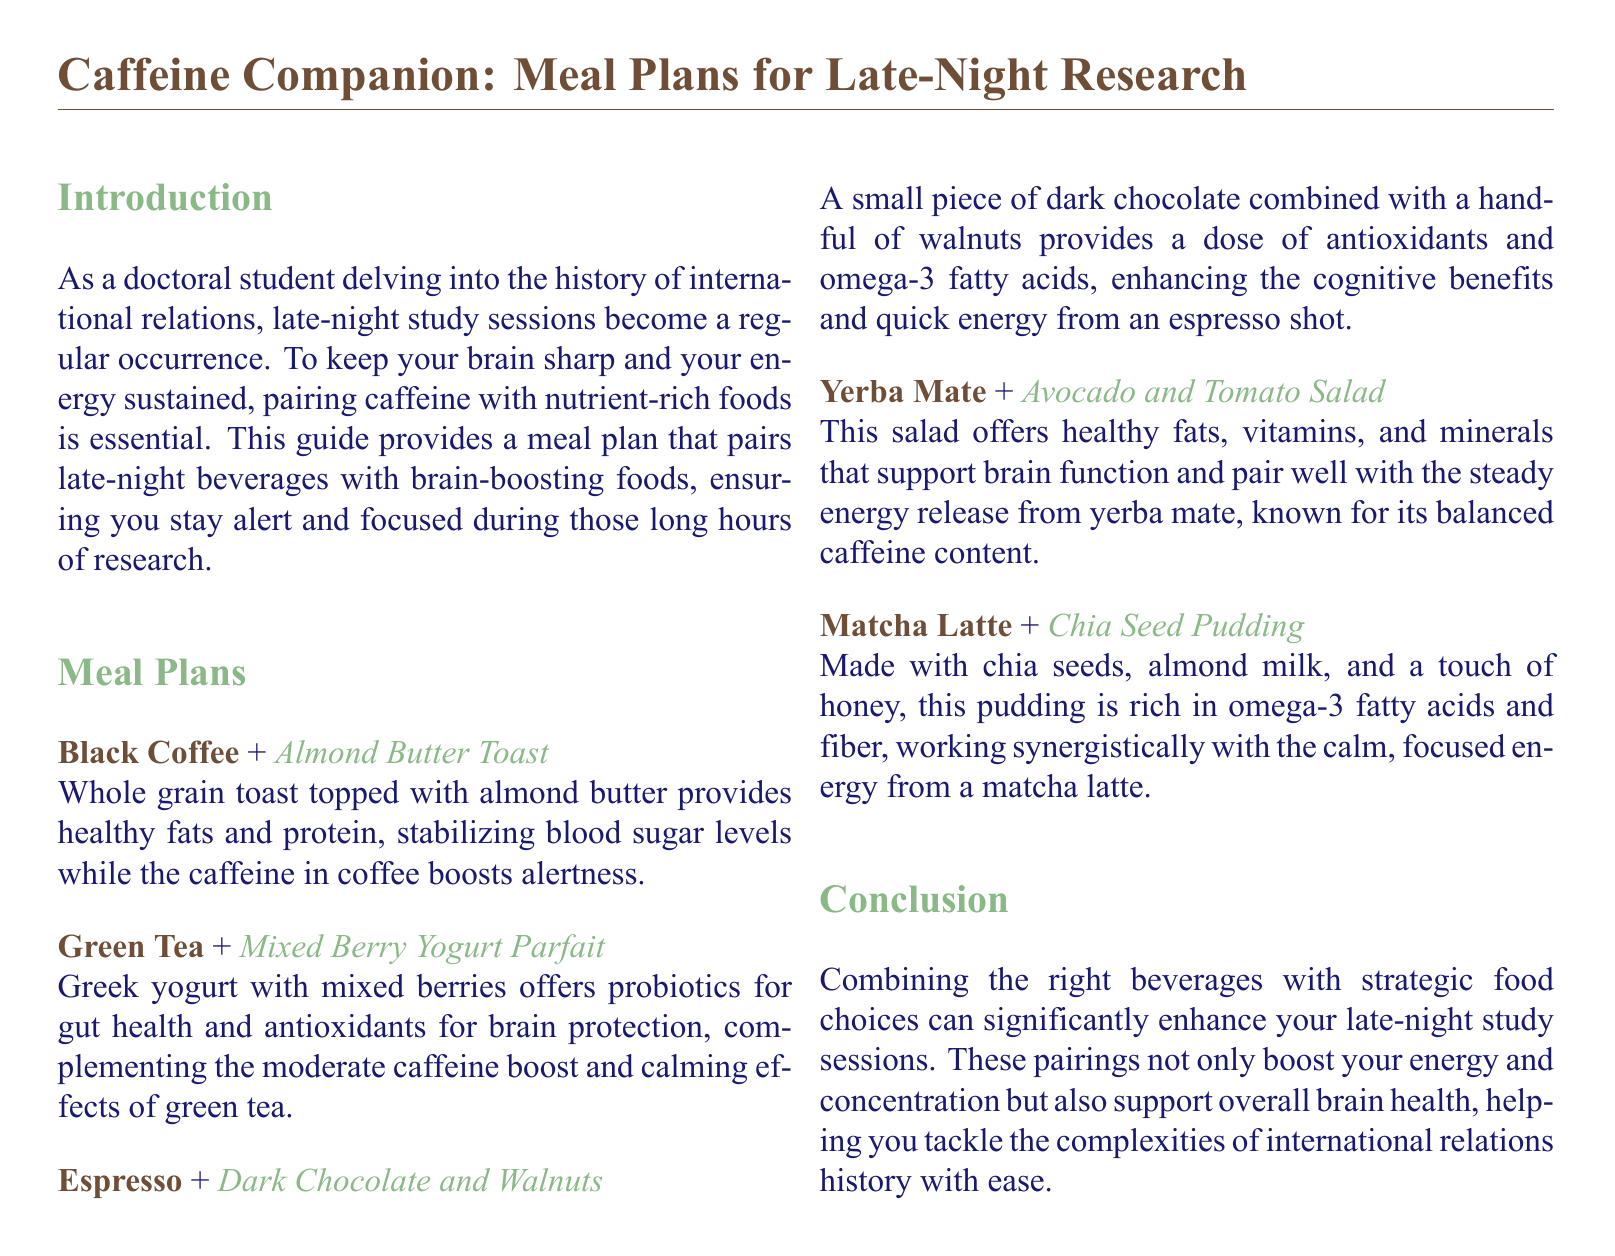what is the first beverage pairing listed in the meal plan? The first beverage pairing in the meal plan is Black Coffee paired with Almond Butter Toast.
Answer: Black Coffee + Almond Butter Toast what food is paired with Green Tea? The food paired with Green Tea is Mixed Berry Yogurt Parfait.
Answer: Mixed Berry Yogurt Parfait how many meal pairings are provided in the document? There are five meal pairings provided in the document.
Answer: 5 what type of food is included in the Espresso pairing? The food included in the Espresso pairing is Dark Chocolate and Walnuts.
Answer: Dark Chocolate and Walnuts what is the benefit of combining Dark Chocolate with Espresso? Dark Chocolate provides antioxidants and omega-3 fatty acids that enhance cognitive benefits when combined with Espresso.
Answer: Antioxidants and omega-3 fatty acids what does the Matcha Latte pairing include? The Matcha Latte pairing includes Chia Seed Pudding.
Answer: Chia Seed Pudding what is a key benefit of the Yogurt Parfait? The Yogurt Parfait offers probiotics for gut health.
Answer: Probiotics for gut health which salad is recommended with Yerba Mate? The recommended salad with Yerba Mate is Avocado and Tomato Salad.
Answer: Avocado and Tomato Salad what is the main focus of the document? The main focus of the document is to provide meal plans that enhance late-night study sessions.
Answer: Meal plans for late-night study sessions 